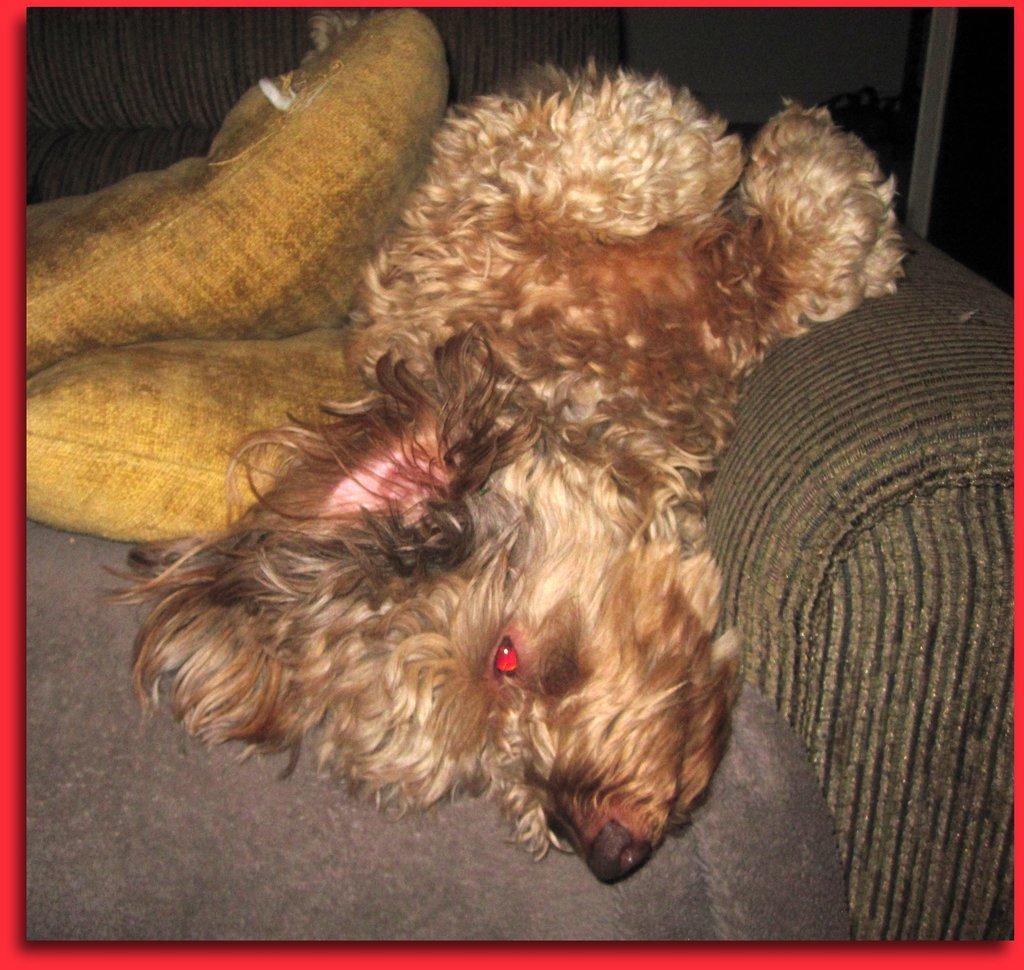Describe this image in one or two sentences. In the image we can see the poster, in the poster we can see the couch, on the couch we can see the pillows and here it looks like a puppy. 